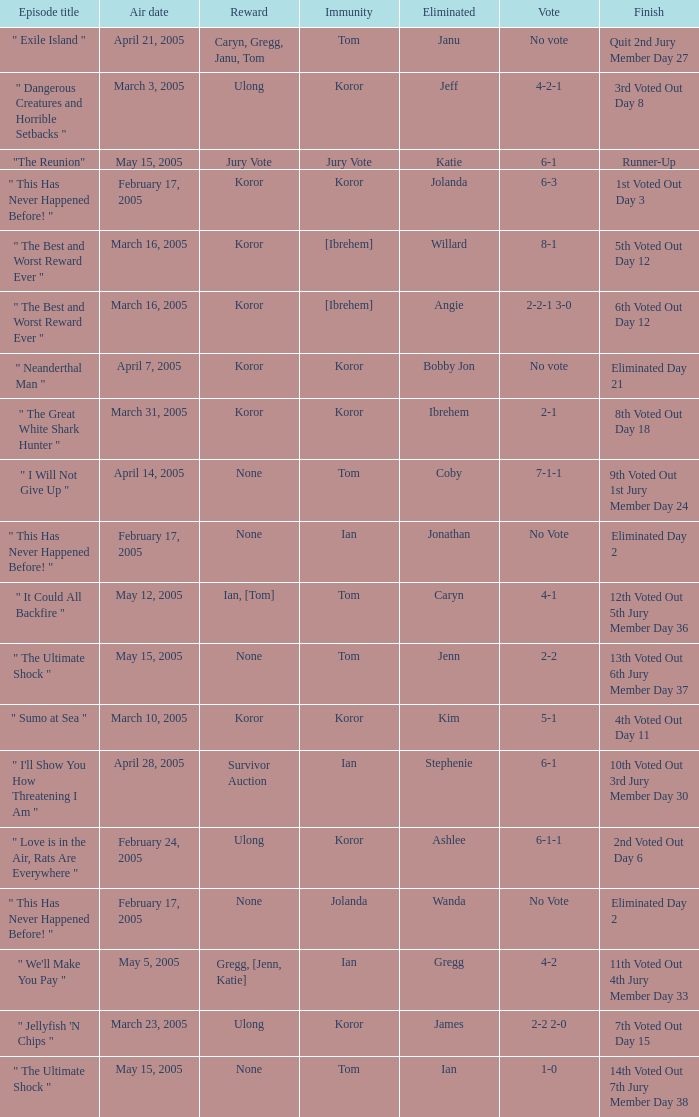What was the vote on the episode where the finish was "10th voted out 3rd jury member day 30"? 6-1. 